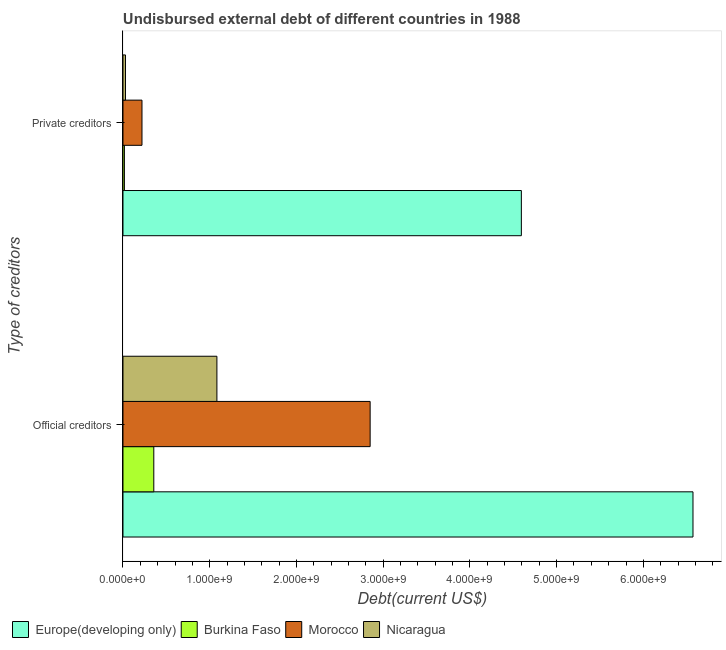How many different coloured bars are there?
Make the answer very short. 4. How many groups of bars are there?
Your response must be concise. 2. Are the number of bars per tick equal to the number of legend labels?
Keep it short and to the point. Yes. Are the number of bars on each tick of the Y-axis equal?
Offer a very short reply. Yes. How many bars are there on the 1st tick from the top?
Make the answer very short. 4. What is the label of the 2nd group of bars from the top?
Your response must be concise. Official creditors. What is the undisbursed external debt of official creditors in Morocco?
Your answer should be compact. 2.85e+09. Across all countries, what is the maximum undisbursed external debt of official creditors?
Make the answer very short. 6.57e+09. Across all countries, what is the minimum undisbursed external debt of official creditors?
Provide a succinct answer. 3.55e+08. In which country was the undisbursed external debt of official creditors maximum?
Ensure brevity in your answer.  Europe(developing only). In which country was the undisbursed external debt of private creditors minimum?
Keep it short and to the point. Burkina Faso. What is the total undisbursed external debt of official creditors in the graph?
Your answer should be compact. 1.09e+1. What is the difference between the undisbursed external debt of official creditors in Burkina Faso and that in Morocco?
Your response must be concise. -2.49e+09. What is the difference between the undisbursed external debt of private creditors in Burkina Faso and the undisbursed external debt of official creditors in Nicaragua?
Your answer should be compact. -1.07e+09. What is the average undisbursed external debt of official creditors per country?
Provide a succinct answer. 2.72e+09. What is the difference between the undisbursed external debt of official creditors and undisbursed external debt of private creditors in Nicaragua?
Keep it short and to the point. 1.05e+09. What is the ratio of the undisbursed external debt of private creditors in Europe(developing only) to that in Nicaragua?
Offer a terse response. 159.17. What does the 2nd bar from the top in Private creditors represents?
Keep it short and to the point. Morocco. What does the 2nd bar from the bottom in Official creditors represents?
Ensure brevity in your answer.  Burkina Faso. How many bars are there?
Offer a very short reply. 8. Are all the bars in the graph horizontal?
Make the answer very short. Yes. What is the difference between two consecutive major ticks on the X-axis?
Give a very brief answer. 1.00e+09. Does the graph contain grids?
Provide a succinct answer. No. Where does the legend appear in the graph?
Your answer should be compact. Bottom left. How many legend labels are there?
Offer a very short reply. 4. What is the title of the graph?
Ensure brevity in your answer.  Undisbursed external debt of different countries in 1988. What is the label or title of the X-axis?
Your answer should be compact. Debt(current US$). What is the label or title of the Y-axis?
Provide a short and direct response. Type of creditors. What is the Debt(current US$) of Europe(developing only) in Official creditors?
Your answer should be compact. 6.57e+09. What is the Debt(current US$) of Burkina Faso in Official creditors?
Ensure brevity in your answer.  3.55e+08. What is the Debt(current US$) of Morocco in Official creditors?
Ensure brevity in your answer.  2.85e+09. What is the Debt(current US$) of Nicaragua in Official creditors?
Ensure brevity in your answer.  1.08e+09. What is the Debt(current US$) of Europe(developing only) in Private creditors?
Your answer should be very brief. 4.59e+09. What is the Debt(current US$) of Burkina Faso in Private creditors?
Offer a terse response. 1.64e+07. What is the Debt(current US$) of Morocco in Private creditors?
Your response must be concise. 2.19e+08. What is the Debt(current US$) of Nicaragua in Private creditors?
Offer a terse response. 2.89e+07. Across all Type of creditors, what is the maximum Debt(current US$) of Europe(developing only)?
Make the answer very short. 6.57e+09. Across all Type of creditors, what is the maximum Debt(current US$) of Burkina Faso?
Your answer should be very brief. 3.55e+08. Across all Type of creditors, what is the maximum Debt(current US$) of Morocco?
Offer a very short reply. 2.85e+09. Across all Type of creditors, what is the maximum Debt(current US$) in Nicaragua?
Your response must be concise. 1.08e+09. Across all Type of creditors, what is the minimum Debt(current US$) of Europe(developing only)?
Make the answer very short. 4.59e+09. Across all Type of creditors, what is the minimum Debt(current US$) in Burkina Faso?
Offer a very short reply. 1.64e+07. Across all Type of creditors, what is the minimum Debt(current US$) in Morocco?
Ensure brevity in your answer.  2.19e+08. Across all Type of creditors, what is the minimum Debt(current US$) in Nicaragua?
Provide a succinct answer. 2.89e+07. What is the total Debt(current US$) of Europe(developing only) in the graph?
Your response must be concise. 1.12e+1. What is the total Debt(current US$) of Burkina Faso in the graph?
Provide a short and direct response. 3.72e+08. What is the total Debt(current US$) in Morocco in the graph?
Your answer should be compact. 3.07e+09. What is the total Debt(current US$) in Nicaragua in the graph?
Your answer should be very brief. 1.11e+09. What is the difference between the Debt(current US$) of Europe(developing only) in Official creditors and that in Private creditors?
Your answer should be very brief. 1.98e+09. What is the difference between the Debt(current US$) of Burkina Faso in Official creditors and that in Private creditors?
Your response must be concise. 3.39e+08. What is the difference between the Debt(current US$) of Morocco in Official creditors and that in Private creditors?
Your response must be concise. 2.63e+09. What is the difference between the Debt(current US$) in Nicaragua in Official creditors and that in Private creditors?
Provide a short and direct response. 1.05e+09. What is the difference between the Debt(current US$) of Europe(developing only) in Official creditors and the Debt(current US$) of Burkina Faso in Private creditors?
Offer a terse response. 6.56e+09. What is the difference between the Debt(current US$) in Europe(developing only) in Official creditors and the Debt(current US$) in Morocco in Private creditors?
Provide a succinct answer. 6.35e+09. What is the difference between the Debt(current US$) of Europe(developing only) in Official creditors and the Debt(current US$) of Nicaragua in Private creditors?
Give a very brief answer. 6.54e+09. What is the difference between the Debt(current US$) of Burkina Faso in Official creditors and the Debt(current US$) of Morocco in Private creditors?
Ensure brevity in your answer.  1.36e+08. What is the difference between the Debt(current US$) of Burkina Faso in Official creditors and the Debt(current US$) of Nicaragua in Private creditors?
Offer a terse response. 3.26e+08. What is the difference between the Debt(current US$) of Morocco in Official creditors and the Debt(current US$) of Nicaragua in Private creditors?
Provide a short and direct response. 2.82e+09. What is the average Debt(current US$) in Europe(developing only) per Type of creditors?
Offer a terse response. 5.58e+09. What is the average Debt(current US$) of Burkina Faso per Type of creditors?
Your answer should be compact. 1.86e+08. What is the average Debt(current US$) of Morocco per Type of creditors?
Keep it short and to the point. 1.53e+09. What is the average Debt(current US$) of Nicaragua per Type of creditors?
Provide a succinct answer. 5.56e+08. What is the difference between the Debt(current US$) of Europe(developing only) and Debt(current US$) of Burkina Faso in Official creditors?
Your answer should be very brief. 6.22e+09. What is the difference between the Debt(current US$) in Europe(developing only) and Debt(current US$) in Morocco in Official creditors?
Your answer should be very brief. 3.72e+09. What is the difference between the Debt(current US$) in Europe(developing only) and Debt(current US$) in Nicaragua in Official creditors?
Your answer should be compact. 5.49e+09. What is the difference between the Debt(current US$) in Burkina Faso and Debt(current US$) in Morocco in Official creditors?
Your answer should be very brief. -2.49e+09. What is the difference between the Debt(current US$) in Burkina Faso and Debt(current US$) in Nicaragua in Official creditors?
Make the answer very short. -7.28e+08. What is the difference between the Debt(current US$) in Morocco and Debt(current US$) in Nicaragua in Official creditors?
Provide a succinct answer. 1.77e+09. What is the difference between the Debt(current US$) of Europe(developing only) and Debt(current US$) of Burkina Faso in Private creditors?
Make the answer very short. 4.58e+09. What is the difference between the Debt(current US$) in Europe(developing only) and Debt(current US$) in Morocco in Private creditors?
Keep it short and to the point. 4.37e+09. What is the difference between the Debt(current US$) in Europe(developing only) and Debt(current US$) in Nicaragua in Private creditors?
Provide a succinct answer. 4.56e+09. What is the difference between the Debt(current US$) in Burkina Faso and Debt(current US$) in Morocco in Private creditors?
Offer a terse response. -2.03e+08. What is the difference between the Debt(current US$) of Burkina Faso and Debt(current US$) of Nicaragua in Private creditors?
Offer a very short reply. -1.24e+07. What is the difference between the Debt(current US$) of Morocco and Debt(current US$) of Nicaragua in Private creditors?
Ensure brevity in your answer.  1.90e+08. What is the ratio of the Debt(current US$) in Europe(developing only) in Official creditors to that in Private creditors?
Provide a short and direct response. 1.43. What is the ratio of the Debt(current US$) of Burkina Faso in Official creditors to that in Private creditors?
Offer a very short reply. 21.62. What is the ratio of the Debt(current US$) in Morocco in Official creditors to that in Private creditors?
Your answer should be very brief. 13.01. What is the ratio of the Debt(current US$) in Nicaragua in Official creditors to that in Private creditors?
Your answer should be very brief. 37.53. What is the difference between the highest and the second highest Debt(current US$) of Europe(developing only)?
Ensure brevity in your answer.  1.98e+09. What is the difference between the highest and the second highest Debt(current US$) of Burkina Faso?
Provide a succinct answer. 3.39e+08. What is the difference between the highest and the second highest Debt(current US$) of Morocco?
Keep it short and to the point. 2.63e+09. What is the difference between the highest and the second highest Debt(current US$) of Nicaragua?
Make the answer very short. 1.05e+09. What is the difference between the highest and the lowest Debt(current US$) in Europe(developing only)?
Offer a very short reply. 1.98e+09. What is the difference between the highest and the lowest Debt(current US$) in Burkina Faso?
Provide a short and direct response. 3.39e+08. What is the difference between the highest and the lowest Debt(current US$) of Morocco?
Your answer should be compact. 2.63e+09. What is the difference between the highest and the lowest Debt(current US$) of Nicaragua?
Provide a short and direct response. 1.05e+09. 